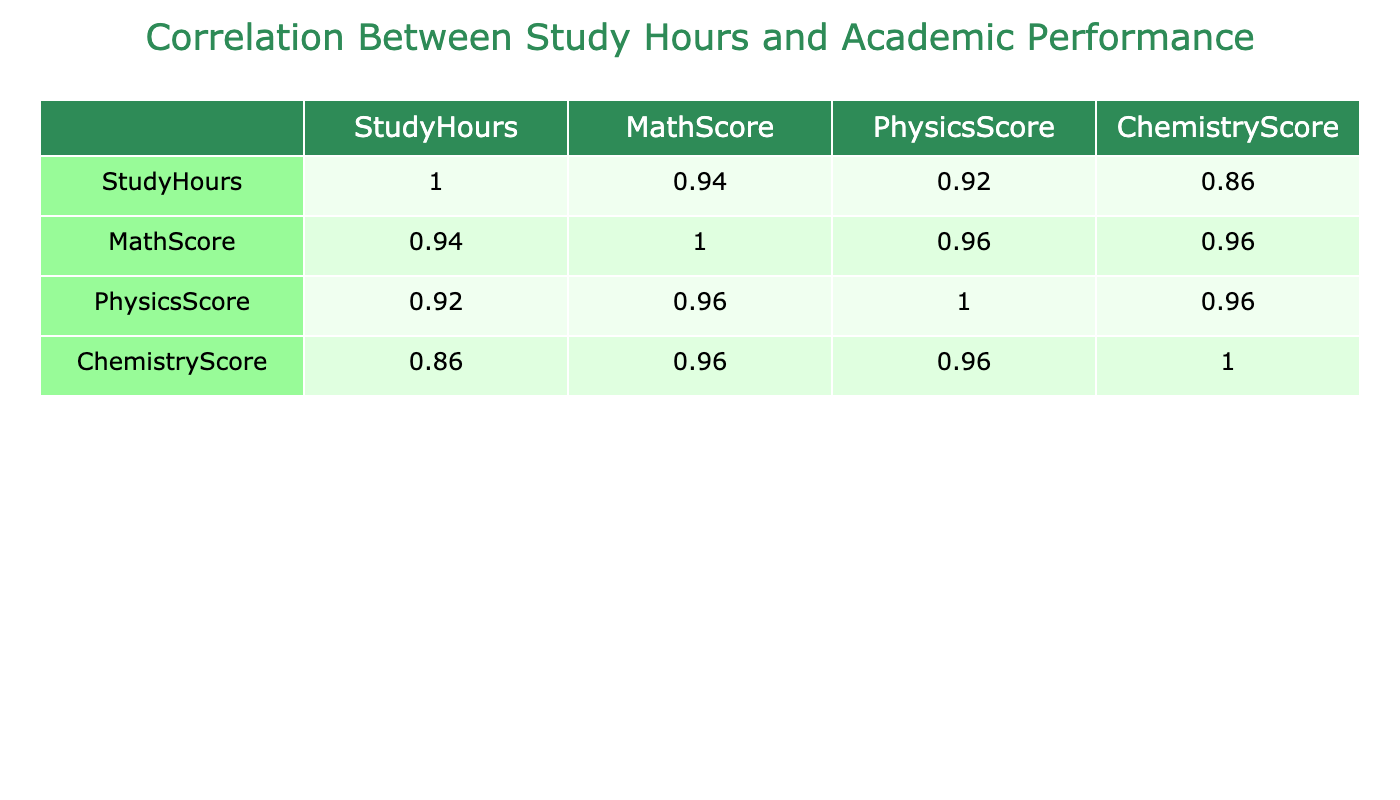What is the correlation coefficient between Study Hours and Math Score? From the correlation table, we can look at the cell where the StudyHours row intersects with the MathScore column. The value there represents the correlation coefficient, which indicates the strength and direction of the linear relationship between these two variables.
Answer: 0.91 What is the lowest score in Chemistry? To find the lowest Chemistry score, we can look down the ChemistryScore column and observe the smallest value. Scanning through the values, we find that the lowest Chemistry score is 70.
Answer: 70 What is the average Physics score for students who studied more than 10 hours? We first identify students with StudyHours greater than 10 and their corresponding PhysicsScores. The students are IDs 2, 6, 9, 11, and 14, who scored 91, 93, 87, 89, and 88 respectively. We sum these scores: 91 + 93 + 87 + 89 + 88 = 448. Since there are 5 students, we divide 448 by 5, giving us an average of 89.6.
Answer: 89.6 Is there a negative correlation between Study Hours and Chemistry Score? To determine if there is a negative correlation, we examine the correlation coefficient between StudyHours and ChemistryScore in the correlation table. A correlation coefficient value greater than 0 indicates a positive relationship, while a value below 0 indicates a negative relationship. In this case, the value is approximately 0.91, which is positive, indicating no negative correlation.
Answer: No Which student has the highest Math Score, and what is that score? We can look at the MathScore column to find the highest value. Reviewing the scores, we find that student ID 6 has the highest Math Score of 95.
Answer: 95 What is the total number of students whose Study Hours are less than or equal to 10? By examining the StudyHours column, we can count the number of students that meet this criterion. The students with StudyHours less than or equal to 10 are IDs 1, 3, 5, 7, 8, 10, 12, and 13, totaling 8 students.
Answer: 8 What is the range of Chemistry scores in the dataset? To find the range of Chemistry scores, we need to subtract the lowest score from the highest score. From the dataset, the highest Chemistry score is 92 (student ID 6), while the lowest is 70 (student ID 10). Therefore, the range is 92 - 70 = 22.
Answer: 22 What percentage of students scored above 80 in both Math and Chemistry? First, we identify students who scored above 80 in Math, which includes IDs 1, 2, 6, 9, 11, and 14 (6 students). Next, we check their Chemistry scores to see if they are also above 80, which includes the same IDs. Since there are 6 successful students out of a total of 15, we calculate (6/15)*100 = 40%.
Answer: 40% 